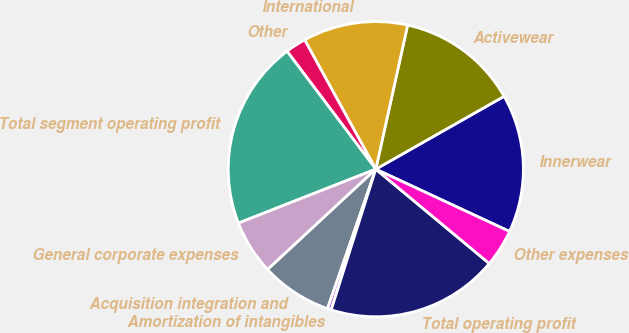Convert chart to OTSL. <chart><loc_0><loc_0><loc_500><loc_500><pie_chart><fcel>Innerwear<fcel>Activewear<fcel>International<fcel>Other<fcel>Total segment operating profit<fcel>General corporate expenses<fcel>Acquisition integration and<fcel>Amortization of intangibles<fcel>Total operating profit<fcel>Other expenses<nl><fcel>15.16%<fcel>13.32%<fcel>11.47%<fcel>2.26%<fcel>20.69%<fcel>5.95%<fcel>7.79%<fcel>0.42%<fcel>18.85%<fcel>4.1%<nl></chart> 